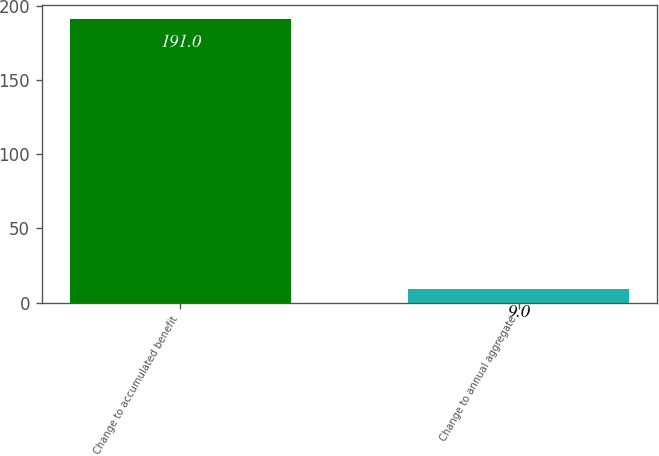Convert chart. <chart><loc_0><loc_0><loc_500><loc_500><bar_chart><fcel>Change to accumulated benefit<fcel>Change to annual aggregate<nl><fcel>191<fcel>9<nl></chart> 